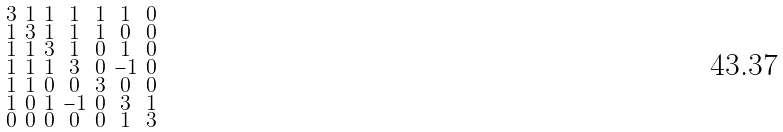<formula> <loc_0><loc_0><loc_500><loc_500>\begin{smallmatrix} 3 & 1 & 1 & 1 & 1 & 1 & 0 \\ 1 & 3 & 1 & 1 & 1 & 0 & 0 \\ 1 & 1 & 3 & 1 & 0 & 1 & 0 \\ 1 & 1 & 1 & 3 & 0 & - 1 & 0 \\ 1 & 1 & 0 & 0 & 3 & 0 & 0 \\ 1 & 0 & 1 & - 1 & 0 & 3 & 1 \\ 0 & 0 & 0 & 0 & 0 & 1 & 3 \end{smallmatrix}</formula> 